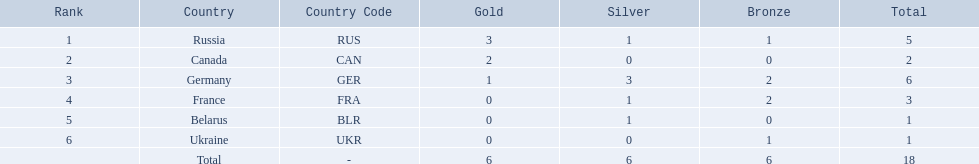Which nations participated? Russia (RUS), Canada (CAN), Germany (GER), France (FRA), Belarus (BLR), Ukraine (UKR). And how many gold medals did they win? 3, 2, 1, 0, 0, 0. What about silver medals? 1, 0, 3, 1, 1, 0. And bronze? 1, 0, 2, 2, 0, 1. Which nation only won gold medals? Canada (CAN). 